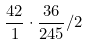<formula> <loc_0><loc_0><loc_500><loc_500>\frac { 4 2 } { 1 } \cdot \frac { 3 6 } { 2 4 5 } / 2</formula> 